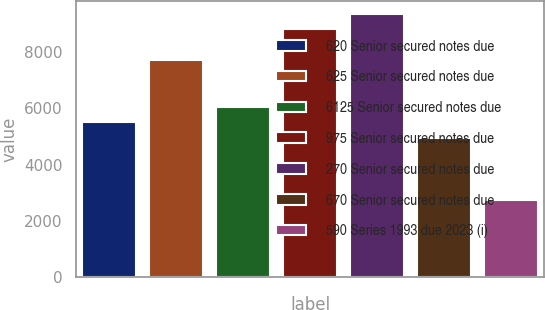Convert chart to OTSL. <chart><loc_0><loc_0><loc_500><loc_500><bar_chart><fcel>620 Senior secured notes due<fcel>625 Senior secured notes due<fcel>6125 Senior secured notes due<fcel>975 Senior secured notes due<fcel>270 Senior secured notes due<fcel>670 Senior secured notes due<fcel>590 Series 1993 due 2023 (i)<nl><fcel>5504<fcel>7704<fcel>6054<fcel>8804<fcel>9354<fcel>4954<fcel>2754<nl></chart> 